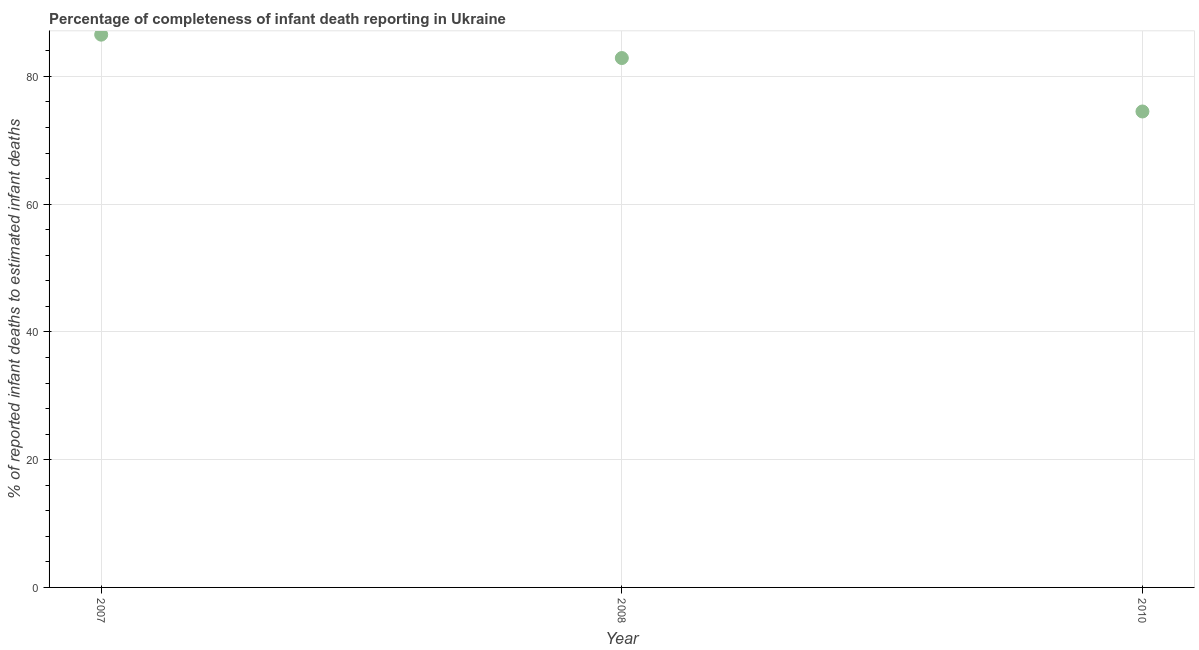What is the completeness of infant death reporting in 2010?
Provide a short and direct response. 74.51. Across all years, what is the maximum completeness of infant death reporting?
Your answer should be compact. 86.54. Across all years, what is the minimum completeness of infant death reporting?
Offer a terse response. 74.51. What is the sum of the completeness of infant death reporting?
Give a very brief answer. 243.93. What is the difference between the completeness of infant death reporting in 2008 and 2010?
Keep it short and to the point. 8.37. What is the average completeness of infant death reporting per year?
Offer a terse response. 81.31. What is the median completeness of infant death reporting?
Offer a very short reply. 82.88. What is the ratio of the completeness of infant death reporting in 2008 to that in 2010?
Your answer should be very brief. 1.11. Is the completeness of infant death reporting in 2007 less than that in 2010?
Offer a very short reply. No. Is the difference between the completeness of infant death reporting in 2008 and 2010 greater than the difference between any two years?
Keep it short and to the point. No. What is the difference between the highest and the second highest completeness of infant death reporting?
Your answer should be very brief. 3.66. Is the sum of the completeness of infant death reporting in 2008 and 2010 greater than the maximum completeness of infant death reporting across all years?
Provide a succinct answer. Yes. What is the difference between the highest and the lowest completeness of infant death reporting?
Offer a terse response. 12.03. In how many years, is the completeness of infant death reporting greater than the average completeness of infant death reporting taken over all years?
Offer a terse response. 2. Does the completeness of infant death reporting monotonically increase over the years?
Provide a succinct answer. No. What is the title of the graph?
Your answer should be very brief. Percentage of completeness of infant death reporting in Ukraine. What is the label or title of the X-axis?
Your response must be concise. Year. What is the label or title of the Y-axis?
Provide a succinct answer. % of reported infant deaths to estimated infant deaths. What is the % of reported infant deaths to estimated infant deaths in 2007?
Make the answer very short. 86.54. What is the % of reported infant deaths to estimated infant deaths in 2008?
Provide a succinct answer. 82.88. What is the % of reported infant deaths to estimated infant deaths in 2010?
Provide a succinct answer. 74.51. What is the difference between the % of reported infant deaths to estimated infant deaths in 2007 and 2008?
Provide a succinct answer. 3.66. What is the difference between the % of reported infant deaths to estimated infant deaths in 2007 and 2010?
Ensure brevity in your answer.  12.03. What is the difference between the % of reported infant deaths to estimated infant deaths in 2008 and 2010?
Your response must be concise. 8.37. What is the ratio of the % of reported infant deaths to estimated infant deaths in 2007 to that in 2008?
Give a very brief answer. 1.04. What is the ratio of the % of reported infant deaths to estimated infant deaths in 2007 to that in 2010?
Offer a very short reply. 1.16. What is the ratio of the % of reported infant deaths to estimated infant deaths in 2008 to that in 2010?
Provide a succinct answer. 1.11. 